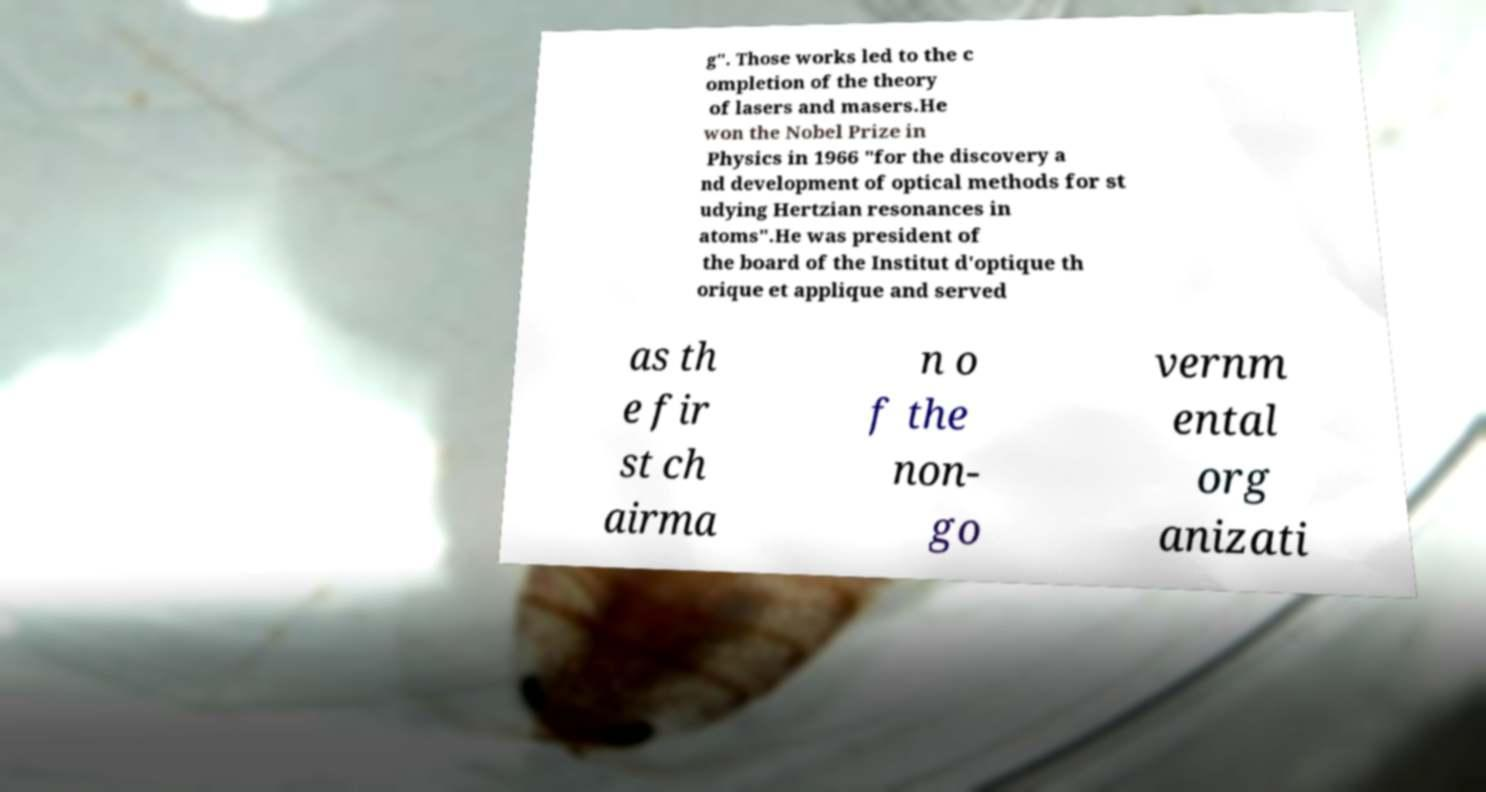Could you assist in decoding the text presented in this image and type it out clearly? g". Those works led to the c ompletion of the theory of lasers and masers.He won the Nobel Prize in Physics in 1966 "for the discovery a nd development of optical methods for st udying Hertzian resonances in atoms".He was president of the board of the Institut d'optique th orique et applique and served as th e fir st ch airma n o f the non- go vernm ental org anizati 